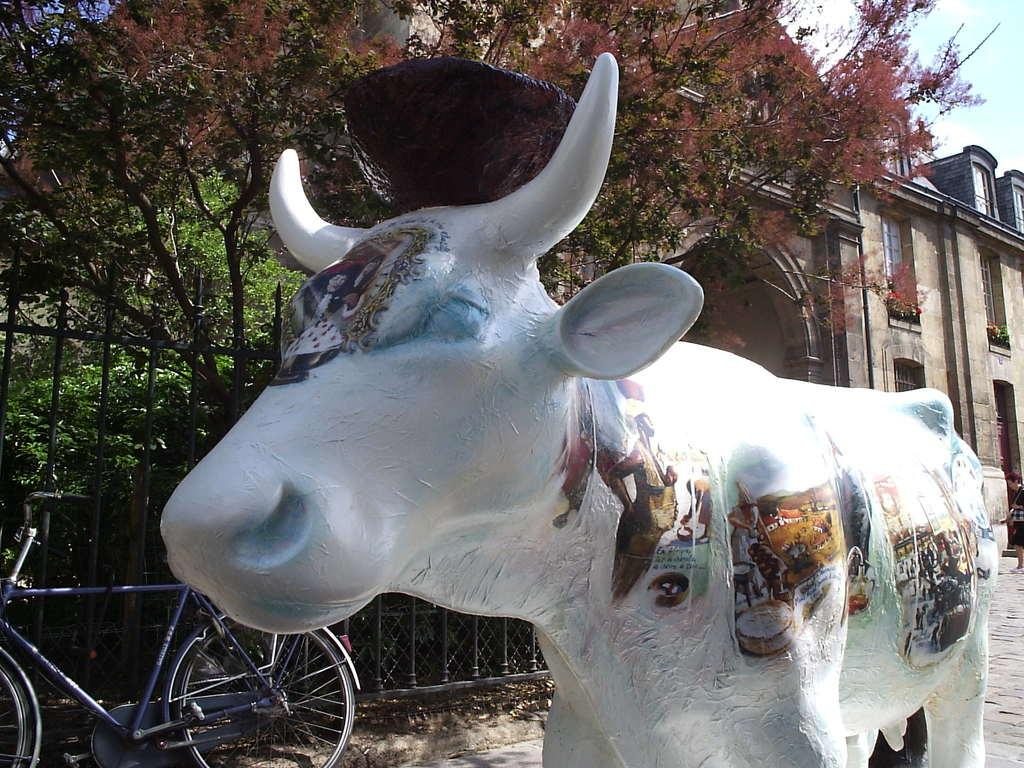What is the main subject of the sculpture in the image? There is a sculpture of a bull in the image. What other objects can be seen in the image? There is a bicycle beside a fence, trees, a building, and a person in the image. What is visible in the background of the image? The sky is visible in the image. What type of event is taking place in the image? There is no indication of an event taking place in the image. The image simply shows a sculpture of a bull, a bicycle, trees, a building, a person, and the sky. 